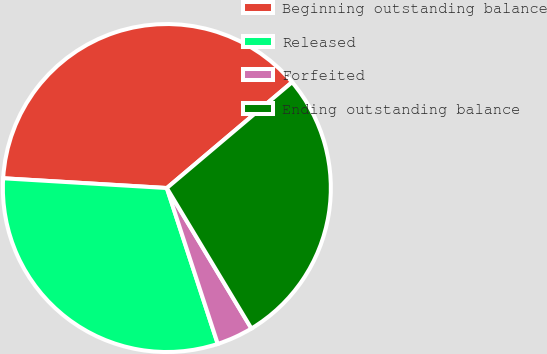Convert chart to OTSL. <chart><loc_0><loc_0><loc_500><loc_500><pie_chart><fcel>Beginning outstanding balance<fcel>Released<fcel>Forfeited<fcel>Ending outstanding balance<nl><fcel>37.88%<fcel>30.97%<fcel>3.6%<fcel>27.54%<nl></chart> 